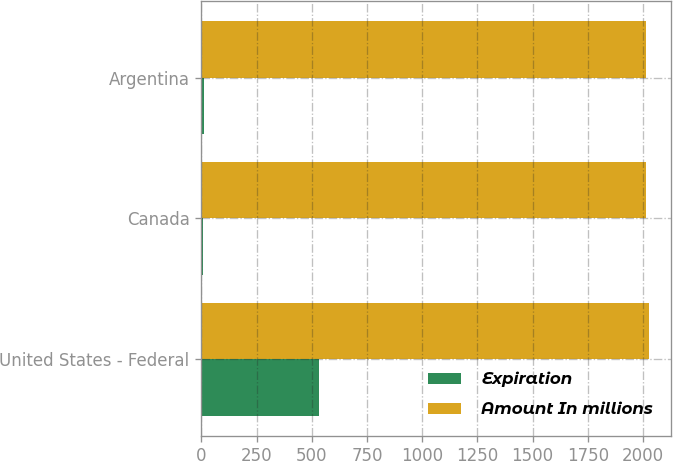Convert chart. <chart><loc_0><loc_0><loc_500><loc_500><stacked_bar_chart><ecel><fcel>United States - Federal<fcel>Canada<fcel>Argentina<nl><fcel>Expiration<fcel>531<fcel>9<fcel>13<nl><fcel>Amount In millions<fcel>2027<fcel>2014<fcel>2012<nl></chart> 